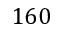Convert formula to latex. <formula><loc_0><loc_0><loc_500><loc_500>1 6 0</formula> 